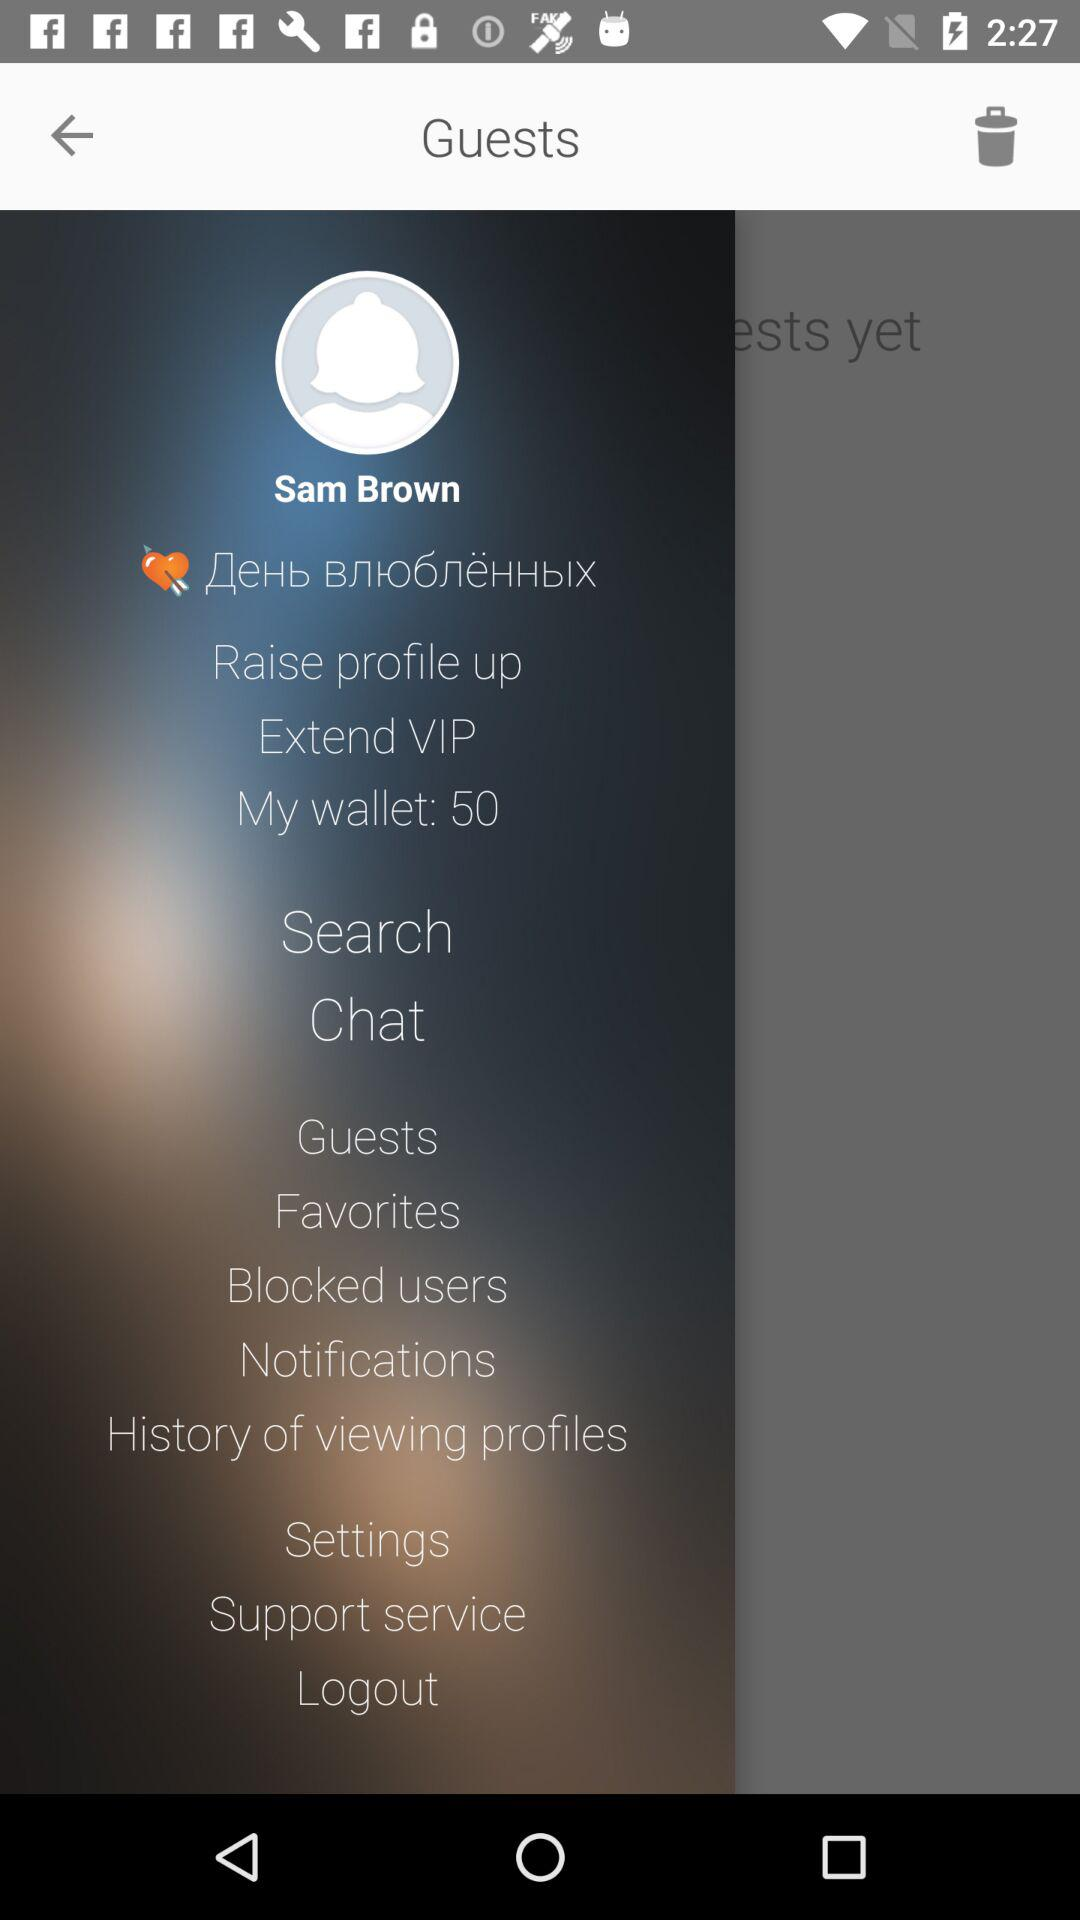What is the total amount of money in the user's wallet?
Answer the question using a single word or phrase. 50 